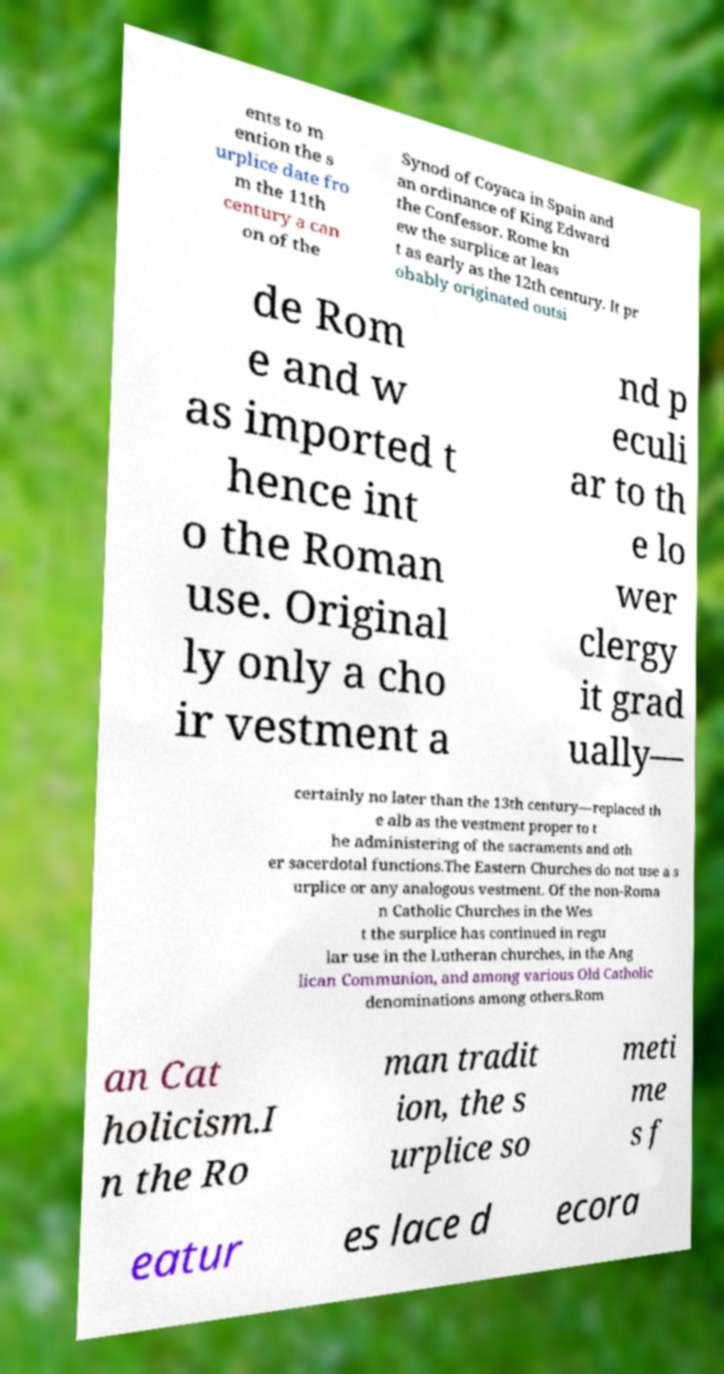Please read and relay the text visible in this image. What does it say? ents to m ention the s urplice date fro m the 11th century a can on of the Synod of Coyaca in Spain and an ordinance of King Edward the Confessor. Rome kn ew the surplice at leas t as early as the 12th century. It pr obably originated outsi de Rom e and w as imported t hence int o the Roman use. Original ly only a cho ir vestment a nd p eculi ar to th e lo wer clergy it grad ually— certainly no later than the 13th century—replaced th e alb as the vestment proper to t he administering of the sacraments and oth er sacerdotal functions.The Eastern Churches do not use a s urplice or any analogous vestment. Of the non-Roma n Catholic Churches in the Wes t the surplice has continued in regu lar use in the Lutheran churches, in the Ang lican Communion, and among various Old Catholic denominations among others.Rom an Cat holicism.I n the Ro man tradit ion, the s urplice so meti me s f eatur es lace d ecora 